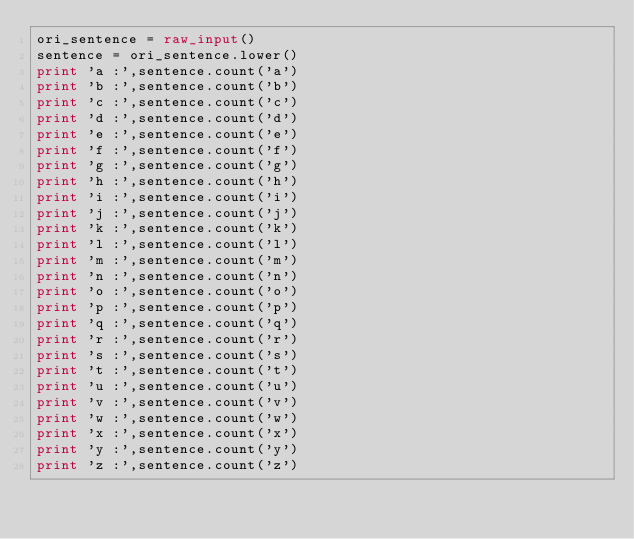Convert code to text. <code><loc_0><loc_0><loc_500><loc_500><_Python_>ori_sentence = raw_input()
sentence = ori_sentence.lower()
print 'a :',sentence.count('a')
print 'b :',sentence.count('b')
print 'c :',sentence.count('c')
print 'd :',sentence.count('d')
print 'e :',sentence.count('e')
print 'f :',sentence.count('f')
print 'g :',sentence.count('g')
print 'h :',sentence.count('h')
print 'i :',sentence.count('i')
print 'j :',sentence.count('j')
print 'k :',sentence.count('k')
print 'l :',sentence.count('l')
print 'm :',sentence.count('m')
print 'n :',sentence.count('n')
print 'o :',sentence.count('o')
print 'p :',sentence.count('p')
print 'q :',sentence.count('q')
print 'r :',sentence.count('r')
print 's :',sentence.count('s')
print 't :',sentence.count('t')
print 'u :',sentence.count('u')
print 'v :',sentence.count('v')
print 'w :',sentence.count('w')
print 'x :',sentence.count('x')
print 'y :',sentence.count('y')
print 'z :',sentence.count('z')</code> 